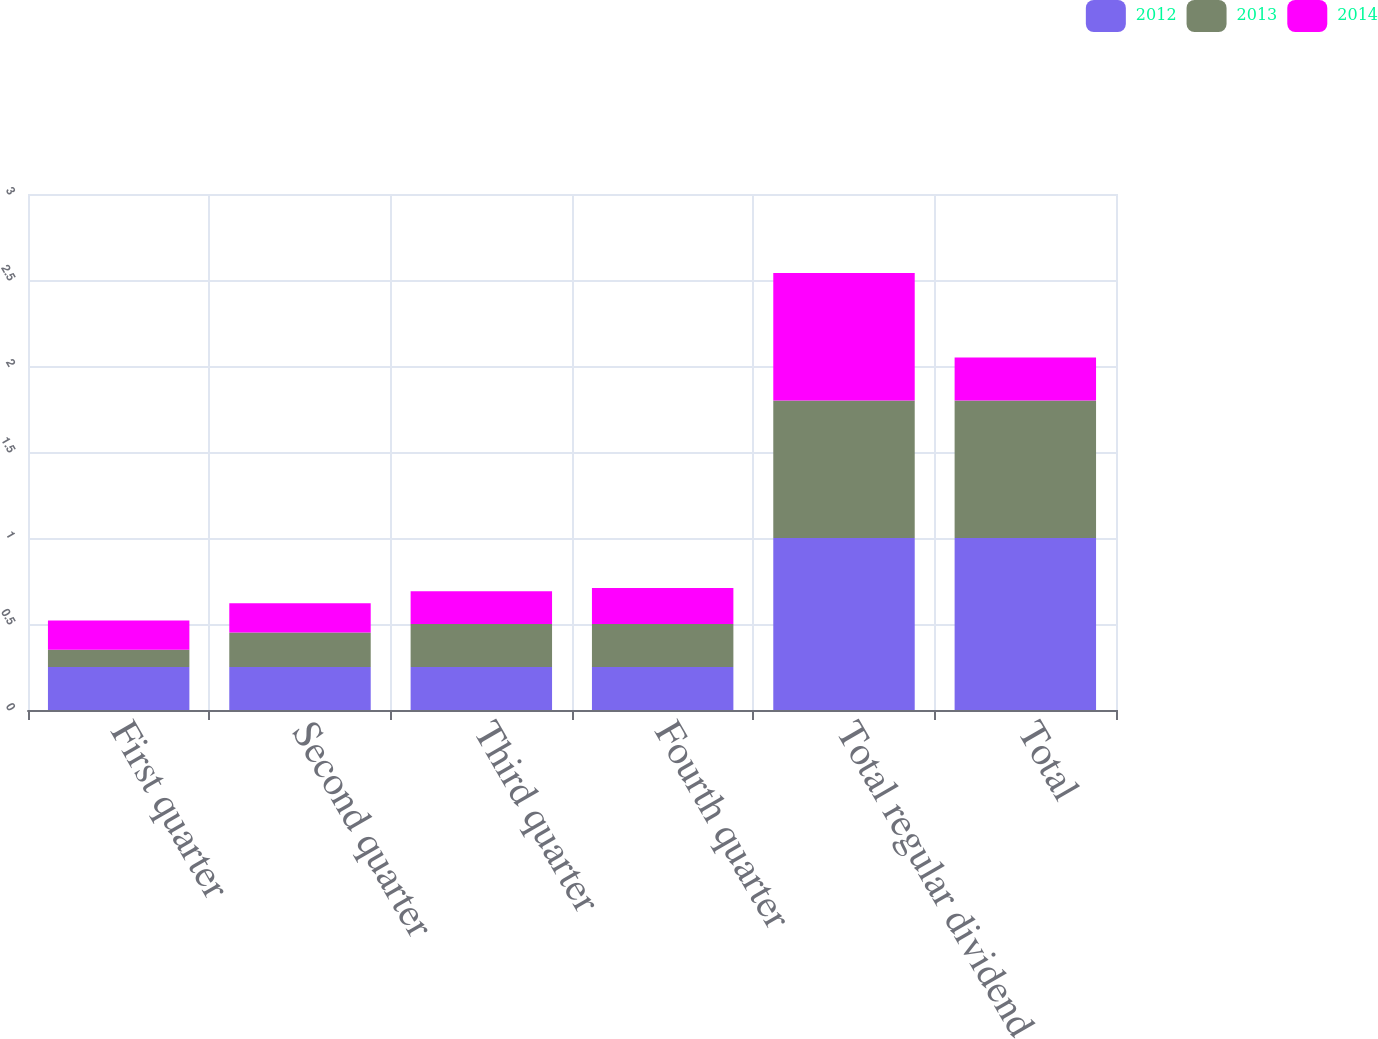Convert chart. <chart><loc_0><loc_0><loc_500><loc_500><stacked_bar_chart><ecel><fcel>First quarter<fcel>Second quarter<fcel>Third quarter<fcel>Fourth quarter<fcel>Total regular dividend<fcel>Total<nl><fcel>2012<fcel>0.25<fcel>0.25<fcel>0.25<fcel>0.25<fcel>1<fcel>1<nl><fcel>2013<fcel>0.1<fcel>0.2<fcel>0.25<fcel>0.25<fcel>0.8<fcel>0.8<nl><fcel>2014<fcel>0.17<fcel>0.17<fcel>0.19<fcel>0.21<fcel>0.74<fcel>0.25<nl></chart> 